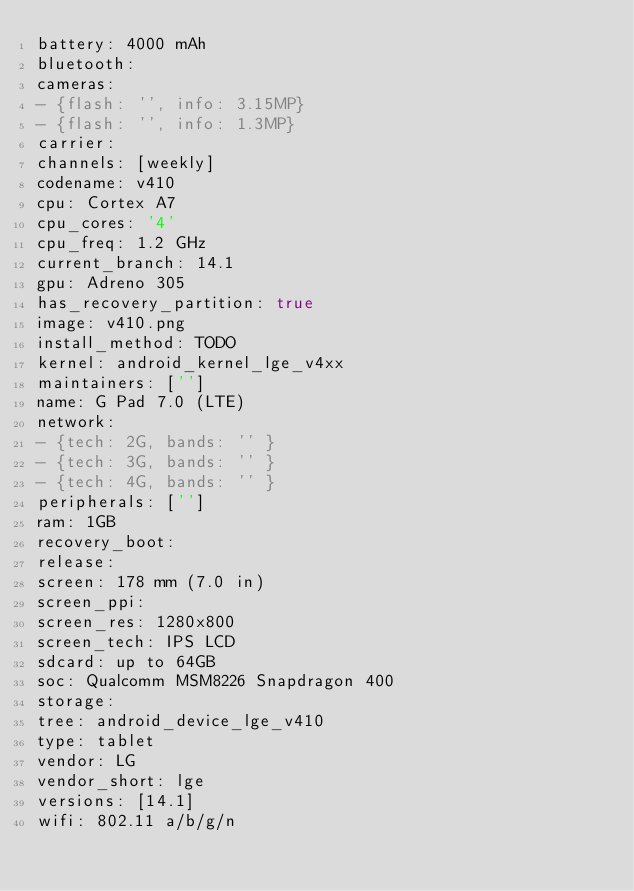<code> <loc_0><loc_0><loc_500><loc_500><_YAML_>battery: 4000 mAh
bluetooth:
cameras:
- {flash: '', info: 3.15MP}
- {flash: '', info: 1.3MP}
carrier:
channels: [weekly]
codename: v410
cpu: Cortex A7
cpu_cores: '4'
cpu_freq: 1.2 GHz
current_branch: 14.1
gpu: Adreno 305
has_recovery_partition: true
image: v410.png
install_method: TODO
kernel: android_kernel_lge_v4xx
maintainers: ['']
name: G Pad 7.0 (LTE)
network:
- {tech: 2G, bands: '' }
- {tech: 3G, bands: '' }
- {tech: 4G, bands: '' }
peripherals: ['']
ram: 1GB
recovery_boot:
release:
screen: 178 mm (7.0 in)
screen_ppi:
screen_res: 1280x800
screen_tech: IPS LCD
sdcard: up to 64GB
soc: Qualcomm MSM8226 Snapdragon 400
storage:
tree: android_device_lge_v410
type: tablet
vendor: LG
vendor_short: lge
versions: [14.1]
wifi: 802.11 a/b/g/n
</code> 